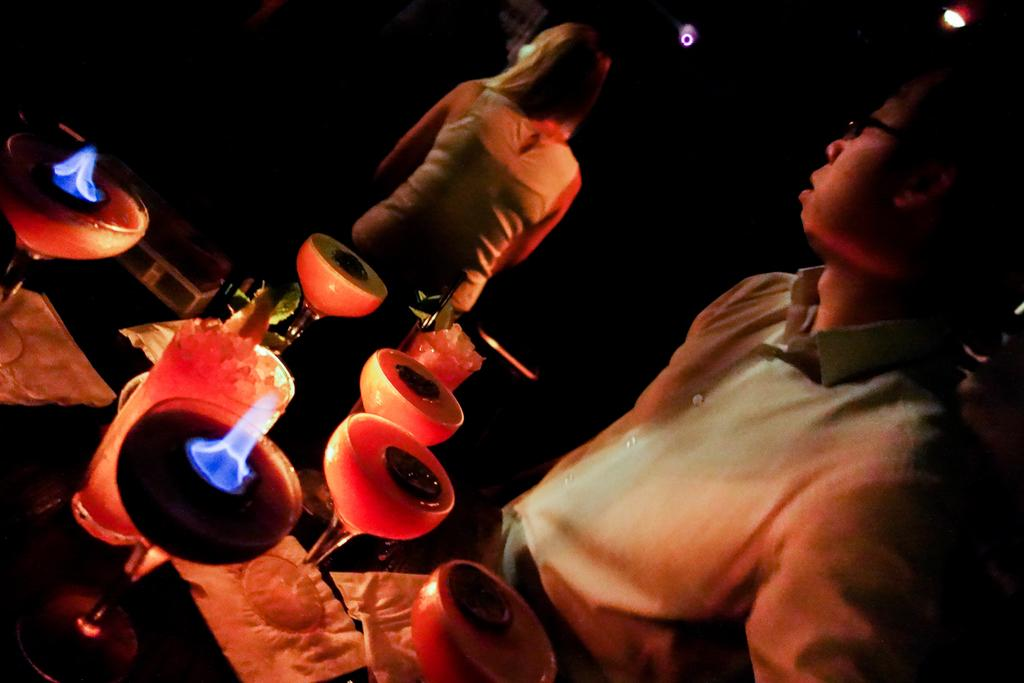Who or what is present in the image? There are people in the image. What objects can be seen in the image? There are glasses and objects on a table in the image. What can be used to see or observe in the image? The glasses in the image can be used to see or observe. What is providing illumination in the image? There are lights visible in the image. What is the color of the background in the image? The background of the image is black. How does the beginner learn to swim in the image? There is no reference to swimming or a beginner in the image, so it is not possible to answer that question. 